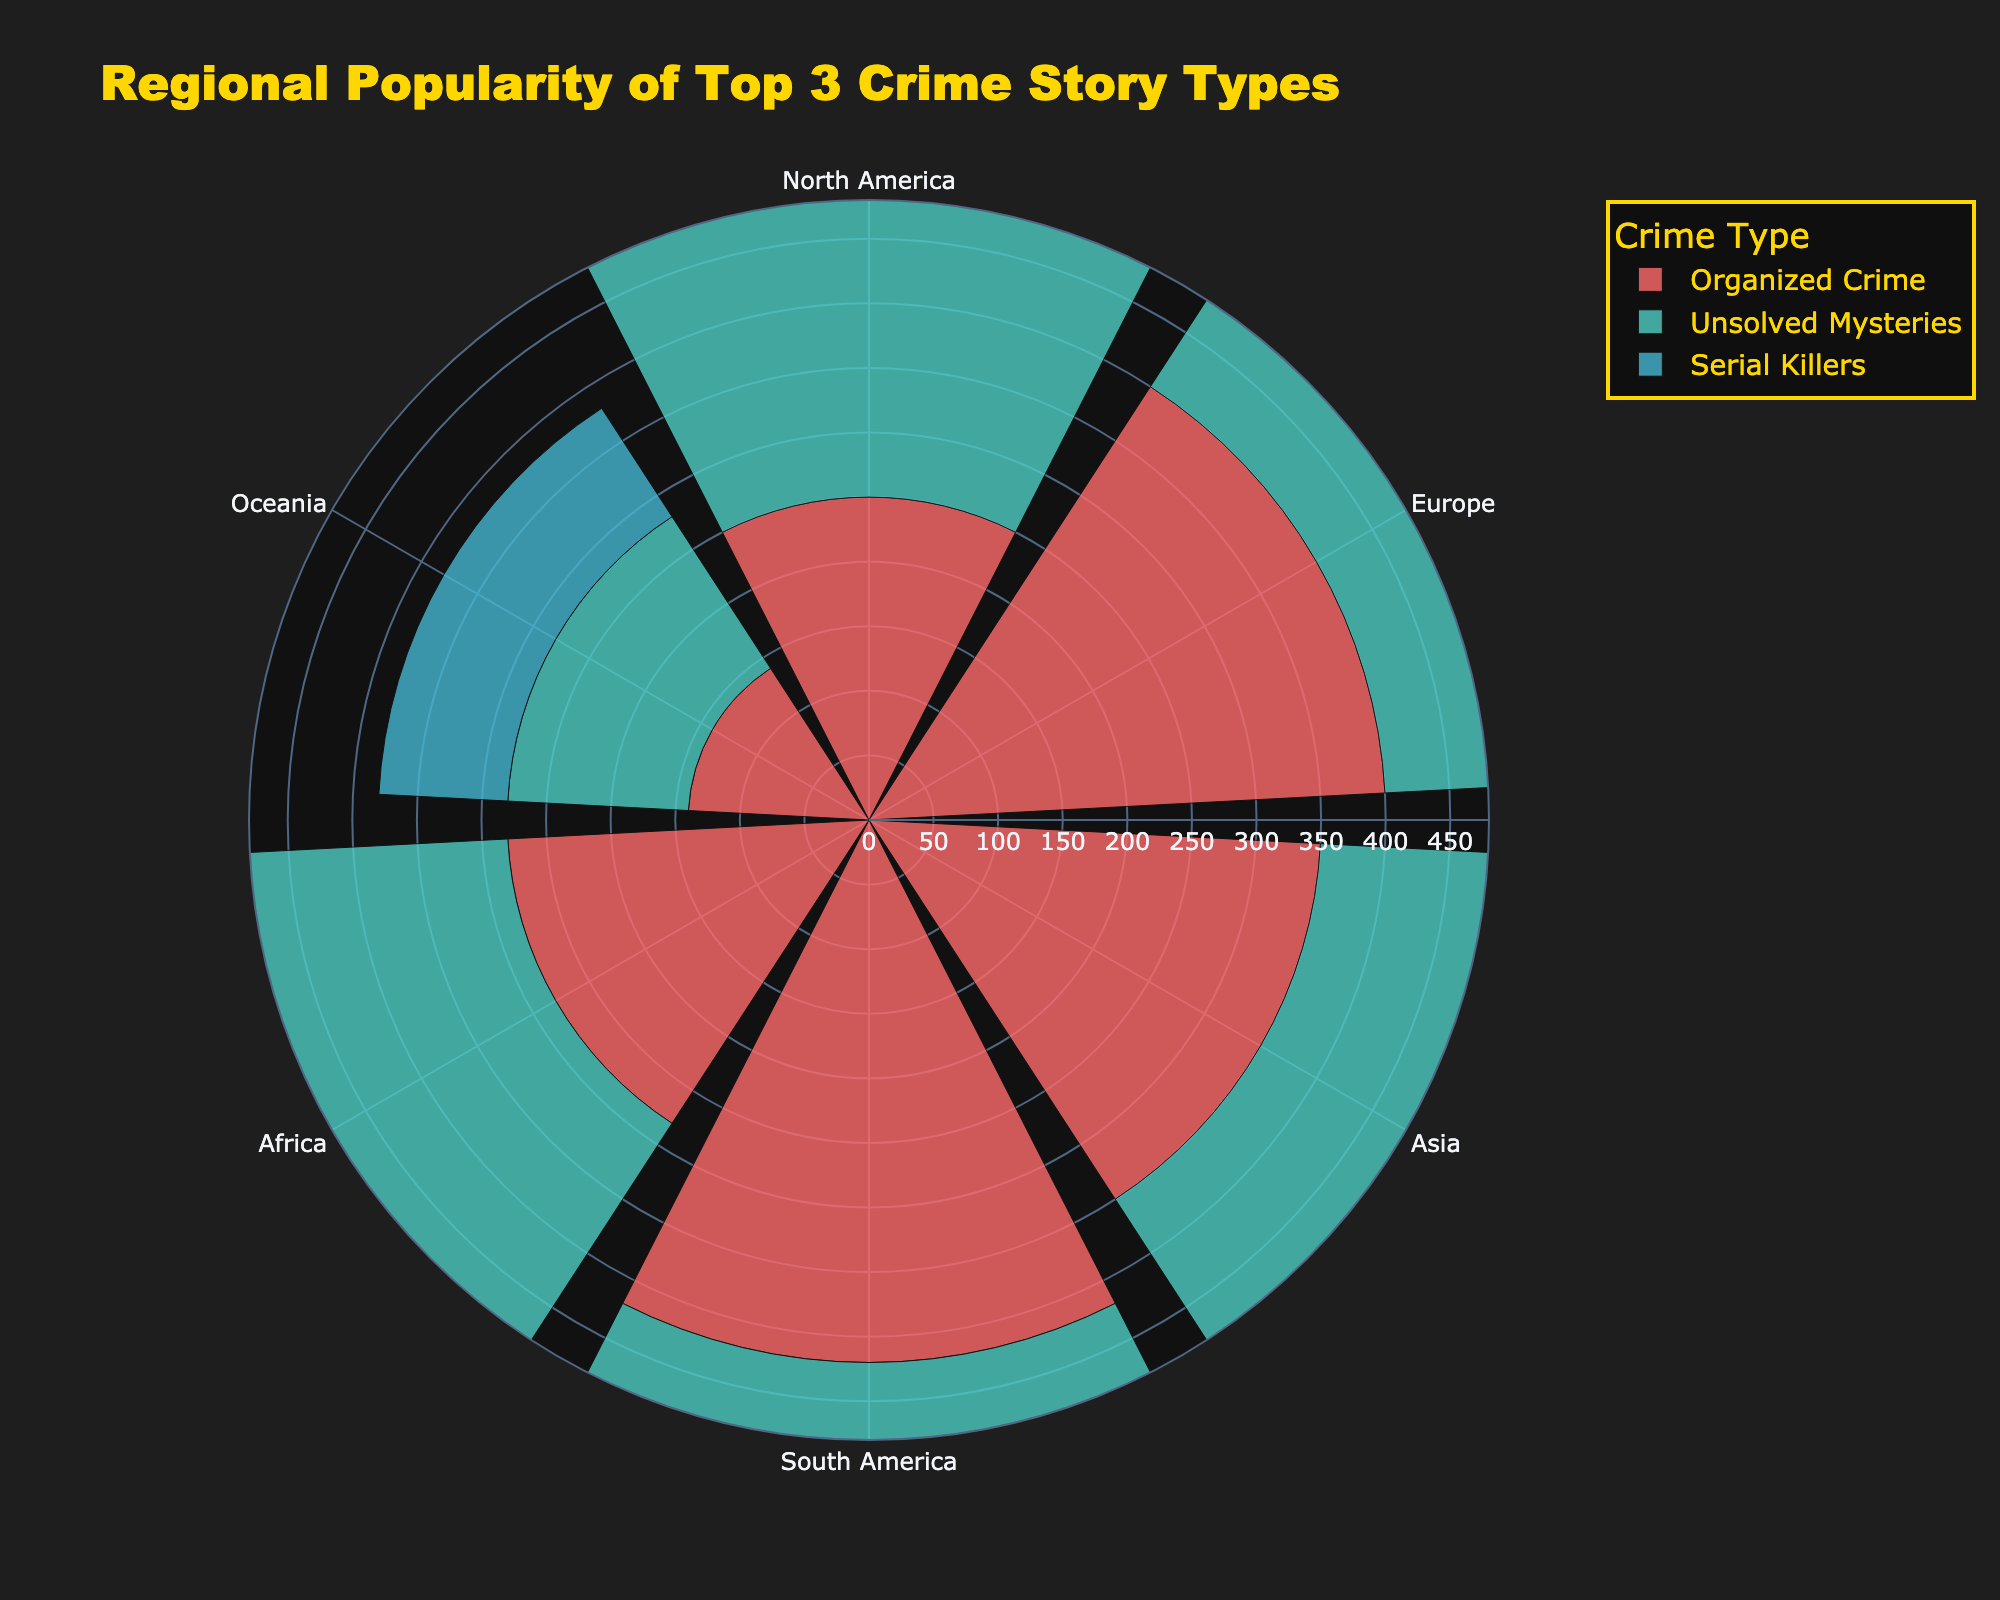What is the title of the rose chart? The title is located at the top center of the rose chart.
Answer: Regional Popularity of Top 3 Crime Story Types Which crime story type has the highest popularity in North America? Look at the bar that represents North America and find the longest radial bar among the listed crime types.
Answer: Serial Killers Of the crime types shown, which one has the lowest popularity in Oceania? Check Oceania and compare the lengths of the radial bars for each crime type to find the shortest one.
Answer: White-Collar Crimes How does the popularity of Organized Crime in Europe compare to that in Asia? Compare the lengths of the radial bars representing Organized Crime for Europe and Asia.
Answer: Europe has higher popularity What is the total combined popularity of Serial Killers and Unsolved Mysteries in North America? Find the values for Serial Killers and Unsolved Mysteries in North America and sum them up: 480 + 370.
Answer: 850 Which region shows the lowest popularity for Serial Killers? Look at all the bars representing Serial Killers across regions and identify the region with the shortest bar.
Answer: Oceania How many different crime types are depicted in the rose chart? Count the different unique names in the legend that correspond to the crime types.
Answer: 3 What is the average popularity of White-Collar Crimes in the depicted regions? Sum the values of White-Collar Crimes across all regions and then divide by the number of regions: (180+160+130+100+90+80) / 6.
Answer: 123.33 Which crime type shows the greatest variance in popularity across all regions? Observe the lengths of the bars for each crime type in all regions and find the one with the greatest differences.
Answer: Serial Killers In which region is Organized Crime most popular? Look at all the bars for Organized Crime and find the longest one to identify the correct region.
Answer: South America 